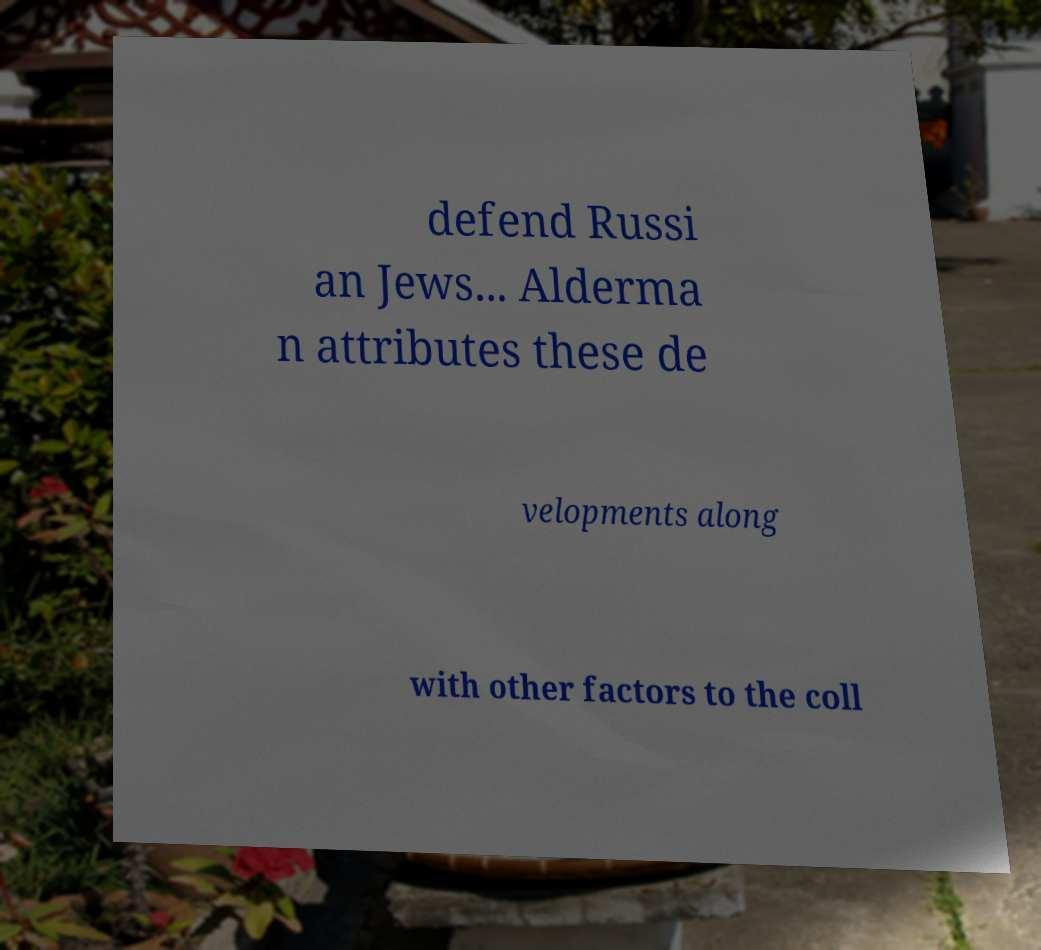Can you read and provide the text displayed in the image?This photo seems to have some interesting text. Can you extract and type it out for me? defend Russi an Jews... Alderma n attributes these de velopments along with other factors to the coll 